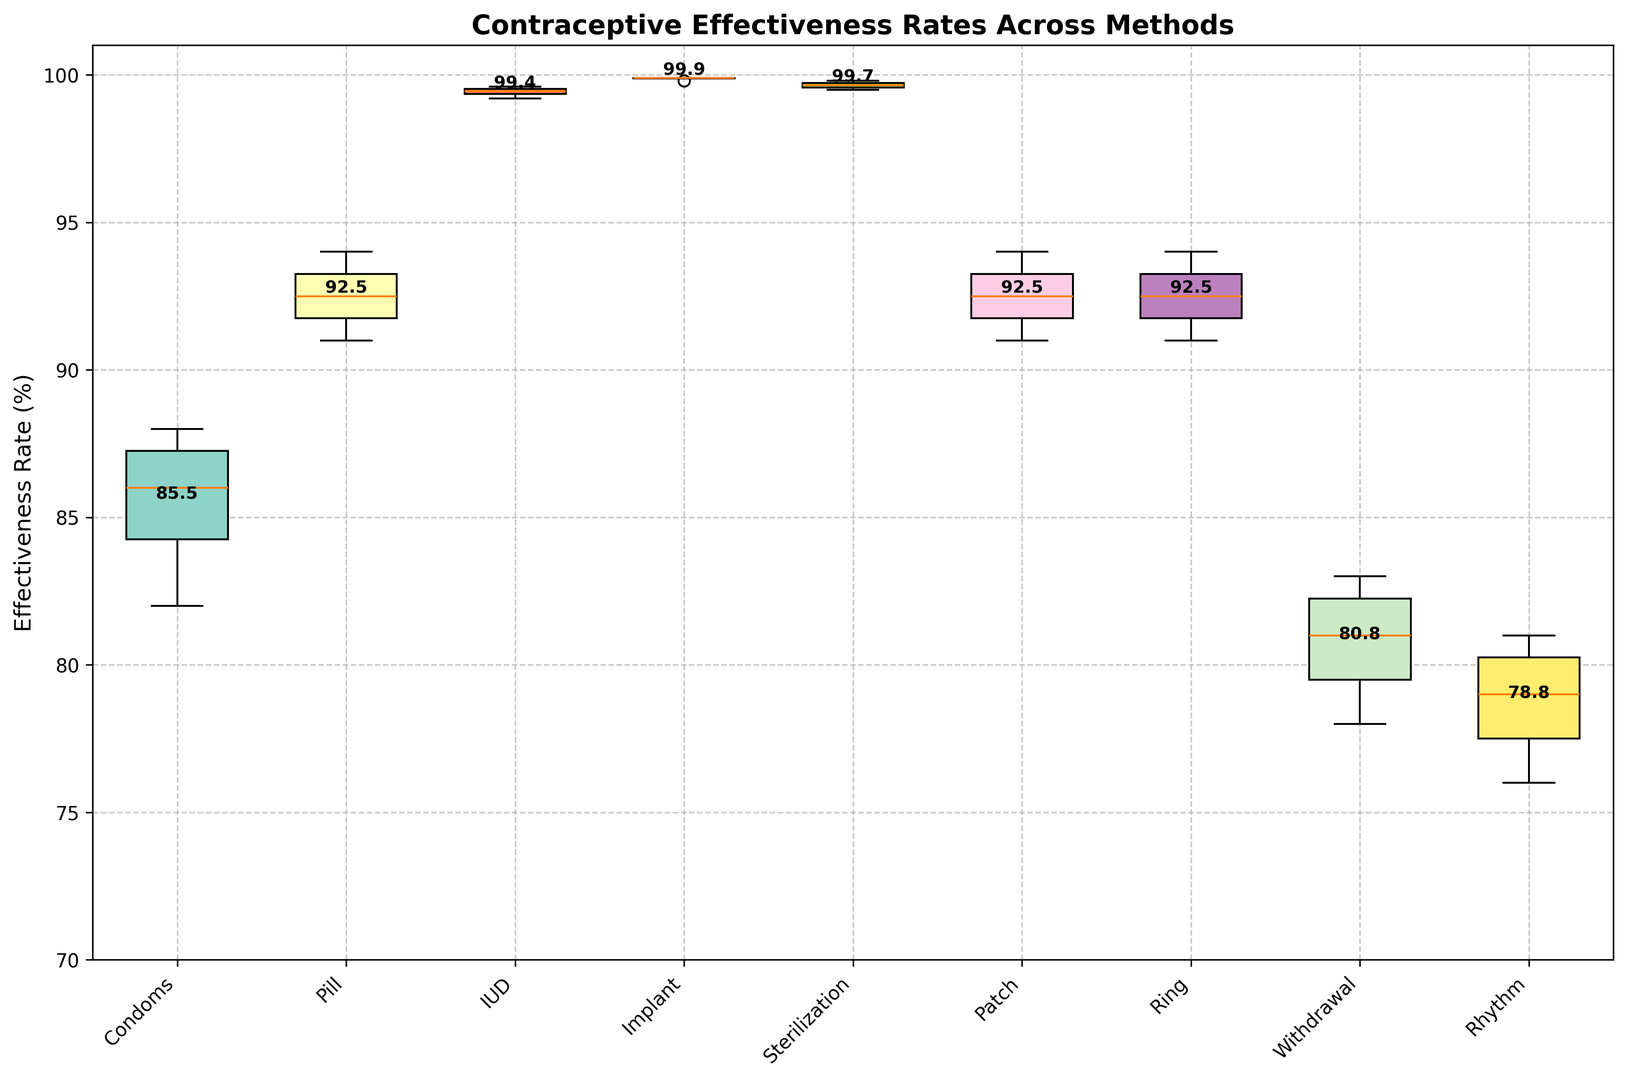What's the range of effectiveness rates for Condoms? To find the range, subtract the minimum effectiveness rate for Condoms (82) from the maximum effectiveness rate for Condoms (88).
Answer: 6 Which contraceptive method has the highest average effectiveness rate? By observing the data points and averaging the values for each method, the Implant shows the highest consistent rates (all near 99.9).
Answer: Implant How does the effectiveness rate of Withdrawal for the 45+ age group compare to the Patch in the same age group? The effectiveness rate for Withdrawal in the 45+ age group is 83, while for the Patch it is 94. Comparing these, Withdrawal is less effective.
Answer: Withdrawal is less effective What's the interquartile range (IQR) of effectiveness rates for the method Pill? The effectiveness rates for the Pill across different age groups are [91, 92, 93, 94]. To find the IQR, calculate Q1 (first quartile, 92) and Q3 (third quartile, 94). IQR = Q3 - Q1.
Answer: 2 Which method shows the most consistent effectiveness rates across age groups? By observing the lengths of the boxes in the plot, the Implant shows the least variation in its effectiveness rates, indicating consistency.
Answer: Implant Compare the median effectiveness rate of IUD with that of the Patch. The median effectiveness rate of IUD can be seen roughly in the middle of its box (99.4), while for the Patch, it's around the middle (92).
Answer: IUD has a higher median How does the effectiveness rate of Sterilization change from the youngest to the oldest age group? The effectiveness rate of Sterilization increases from 99.5 (18-24) to 99.8 (45+).
Answer: It increases What is the overall trend of effectiveness rates as age increases for most methods? From the plot, the effectiveness rates for most methods slightly increase as the age group progresses from 18-24 to 45+.
Answer: Increasing trend Which method has the lowest effectiveness rate among all age groups? The lowest effectiveness rate among all methods and age groups is Rhythm for the 18-24 age group, which is 76.
Answer: Rhythm Are there any methods with effectiveness rates greater than 99% for all age groups? Methods with effectiveness rates greater than 99% across all age groups include IUD, Implant, and Sterilization.
Answer: Yes (IUD, Implant, Sterilization) 